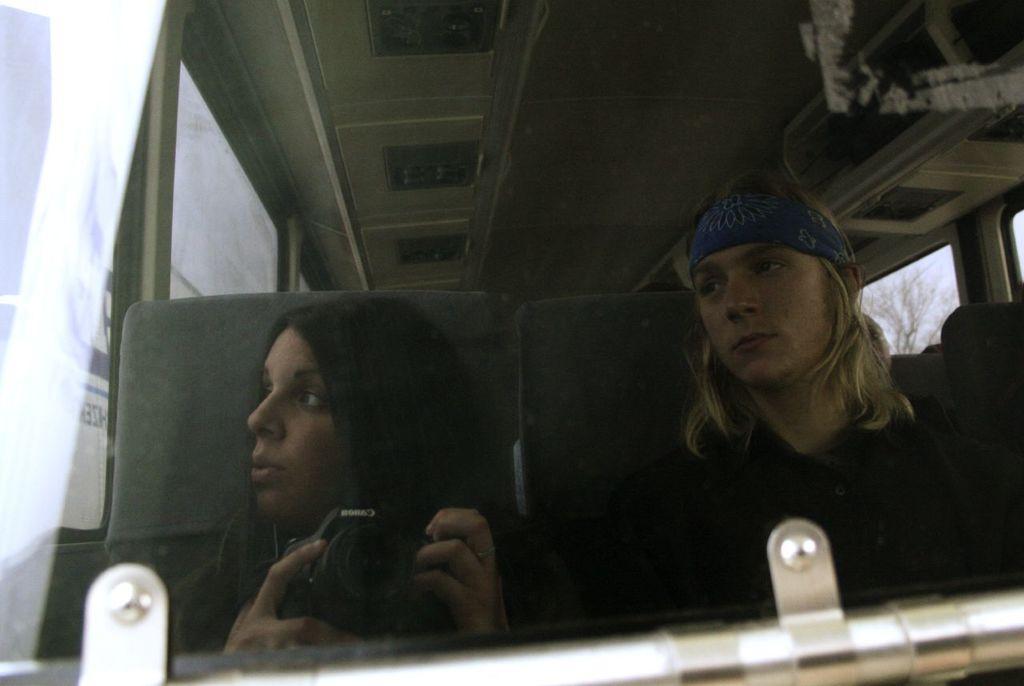Can you describe this image briefly? This image is taken in a bus. In the middle of the image a man and a woman are sitting on the seats. On the left side of the image there are two windows. At the top of the image there is a roof. 